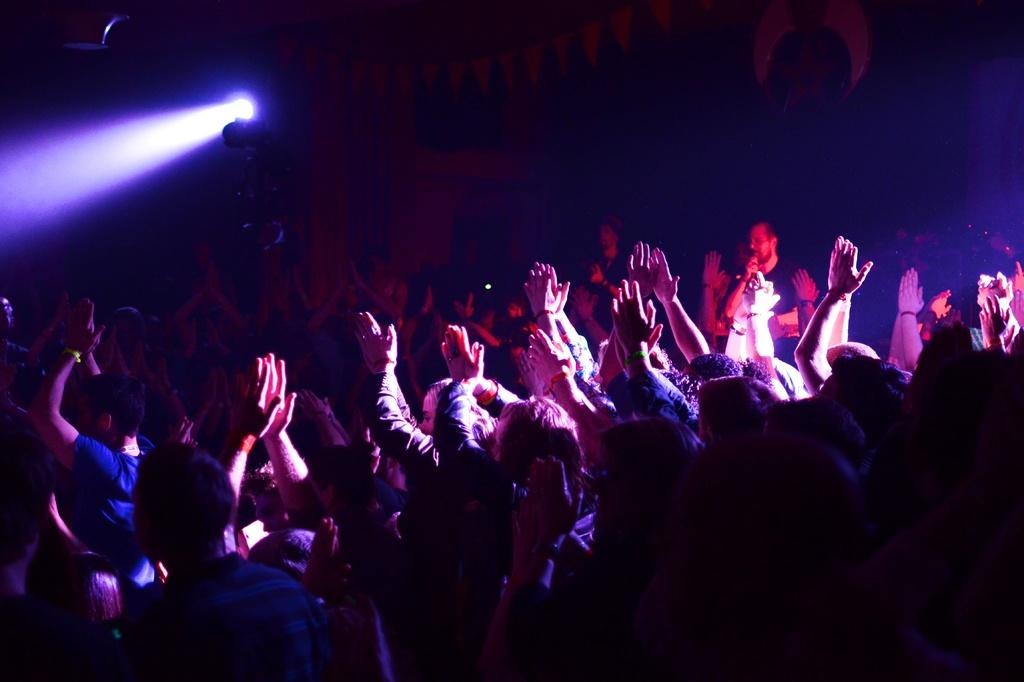Who or what is present in the image? There are people in the image. What are the people doing in the image? The people are clapping their hands. Can you describe any objects or features near the people? There is a light near the persons. What type of tax is being discussed by the people in the image? There is no indication in the image that the people are discussing any type of tax. 